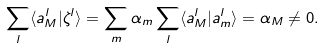Convert formula to latex. <formula><loc_0><loc_0><loc_500><loc_500>\sum _ { l } \langle a _ { M } ^ { l } | \zeta ^ { l } \rangle = \sum _ { m } \alpha _ { m } \sum _ { l } \langle a _ { M } ^ { l } | a _ { m } ^ { l } \rangle = \alpha _ { M } \ne 0 .</formula> 